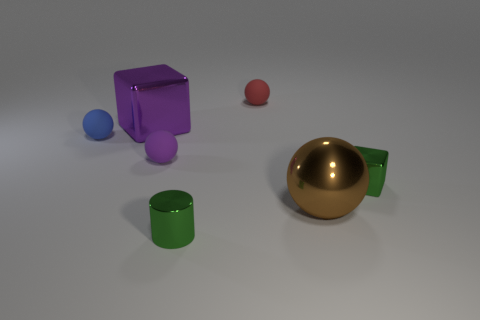There is a tiny thing in front of the large thing right of the tiny purple thing; what is its shape?
Make the answer very short. Cylinder. Do the large metallic block and the tiny rubber object in front of the small blue thing have the same color?
Your answer should be very brief. Yes. The purple metallic object is what shape?
Offer a very short reply. Cube. How big is the block to the left of the small green shiny object to the left of the brown thing?
Provide a succinct answer. Large. Is the number of big purple shiny things that are in front of the small purple rubber sphere the same as the number of green objects right of the green cylinder?
Provide a short and direct response. No. There is a sphere that is to the right of the blue ball and left of the tiny red ball; what material is it?
Keep it short and to the point. Rubber. Does the metal sphere have the same size as the cube that is behind the blue rubber object?
Your response must be concise. Yes. How many other things are there of the same color as the small metallic cylinder?
Your answer should be compact. 1. Is the number of matte things to the right of the blue matte sphere greater than the number of green matte things?
Give a very brief answer. Yes. The tiny shiny thing that is behind the big metal ball to the right of the tiny rubber thing that is left of the purple rubber ball is what color?
Your response must be concise. Green. 